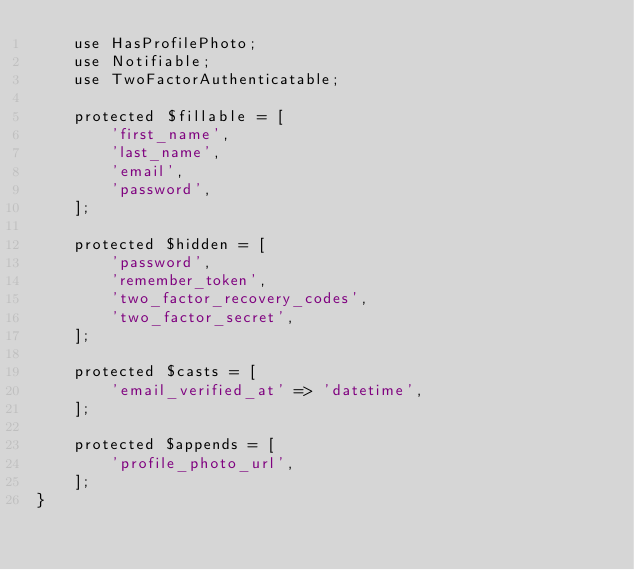Convert code to text. <code><loc_0><loc_0><loc_500><loc_500><_PHP_>    use HasProfilePhoto;
    use Notifiable;
    use TwoFactorAuthenticatable;

    protected $fillable = [
        'first_name',
        'last_name',
        'email',
        'password',
    ];

    protected $hidden = [
        'password',
        'remember_token',
        'two_factor_recovery_codes',
        'two_factor_secret',
    ];

    protected $casts = [
        'email_verified_at' => 'datetime',
    ];

    protected $appends = [
        'profile_photo_url',
    ];
}
</code> 